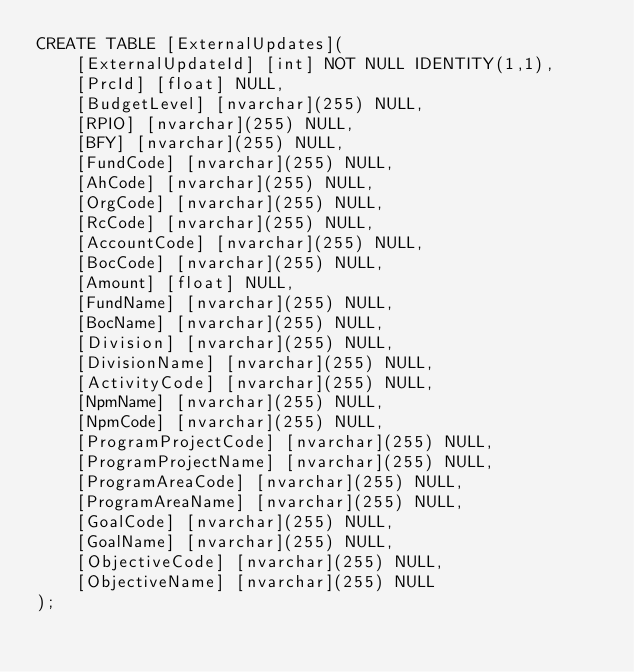<code> <loc_0><loc_0><loc_500><loc_500><_SQL_>CREATE TABLE [ExternalUpdates](
	[ExternalUpdateId] [int] NOT NULL IDENTITY(1,1),
	[PrcId] [float] NULL,
	[BudgetLevel] [nvarchar](255) NULL,
	[RPIO] [nvarchar](255) NULL,
	[BFY] [nvarchar](255) NULL,
	[FundCode] [nvarchar](255) NULL,
	[AhCode] [nvarchar](255) NULL,
	[OrgCode] [nvarchar](255) NULL,
	[RcCode] [nvarchar](255) NULL,
	[AccountCode] [nvarchar](255) NULL,
	[BocCode] [nvarchar](255) NULL,
	[Amount] [float] NULL,
	[FundName] [nvarchar](255) NULL,
	[BocName] [nvarchar](255) NULL,
	[Division] [nvarchar](255) NULL,
	[DivisionName] [nvarchar](255) NULL,
	[ActivityCode] [nvarchar](255) NULL,
	[NpmName] [nvarchar](255) NULL,
	[NpmCode] [nvarchar](255) NULL,
	[ProgramProjectCode] [nvarchar](255) NULL,
	[ProgramProjectName] [nvarchar](255) NULL,
	[ProgramAreaCode] [nvarchar](255) NULL,
	[ProgramAreaName] [nvarchar](255) NULL,
	[GoalCode] [nvarchar](255) NULL,
	[GoalName] [nvarchar](255) NULL,
	[ObjectiveCode] [nvarchar](255) NULL,
	[ObjectiveName] [nvarchar](255) NULL
);

</code> 